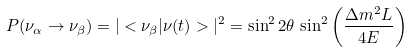Convert formula to latex. <formula><loc_0><loc_0><loc_500><loc_500>P ( \nu _ { \alpha } \rightarrow \nu _ { \beta } ) = | < \nu _ { \beta } | \nu ( t ) > | ^ { 2 } = \sin ^ { 2 } 2 \theta \, \sin ^ { 2 } \left ( \frac { \Delta m ^ { 2 } L } { 4 E } \right )</formula> 